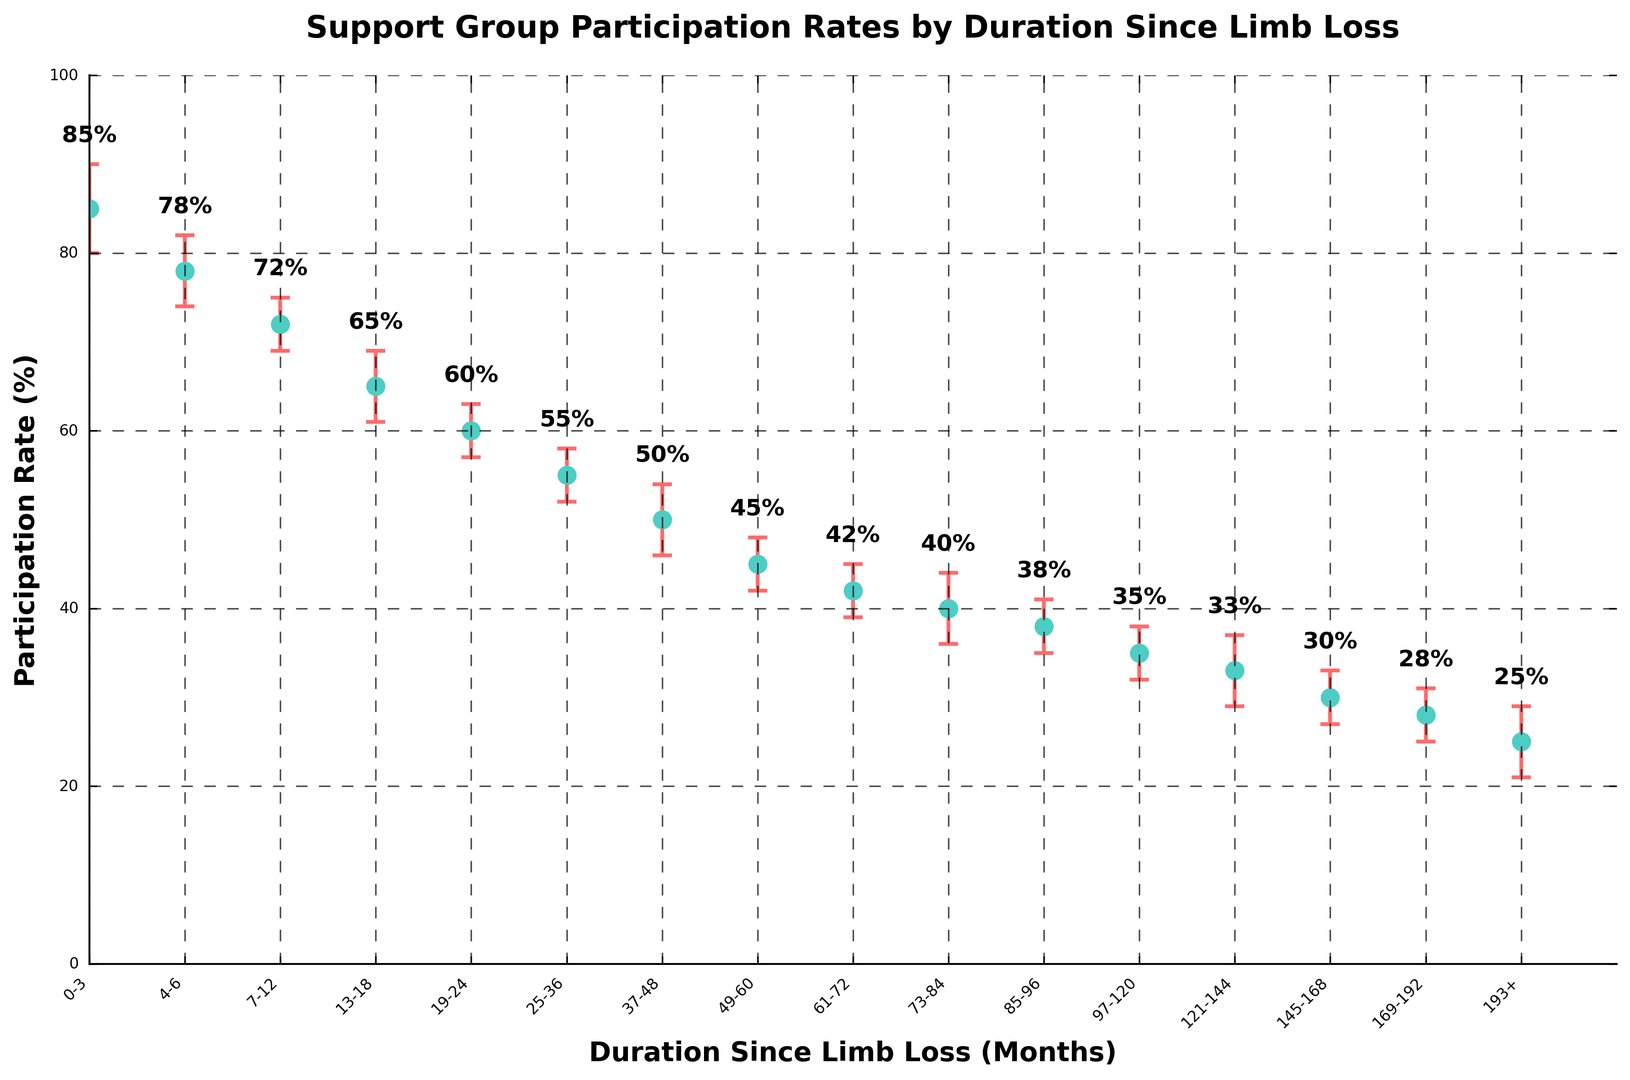Which duration since limb loss has the highest participation rate? To find the duration with the highest participation rate, look at the values on the y-axis and identify the corresponding x-axis label. The highest rate is 85%, and it is for the duration 0-3 months.
Answer: 0-3 months What is the participation rate for those with 4-6 months since limb loss? Locate the 4-6 months label on the x-axis and find the corresponding point on the y-axis. The participation rate is 78%.
Answer: 78% Is the participation rate for 7-12 months greater than or less than the rate for 13-18 months? Compare the participation rates of 72% and 65% for 7-12 months and 13-18 months, respectively. 72% is greater than 65%.
Answer: Greater What is the difference in participation rates between those with 61-72 months and those with 193+ months since limb loss? Locate the points for 61-72 months and 193+ months, which are 42% and 25% respectively. Subtract 25% from 42% to get 17%.
Answer: 17% What is the trend in participation rates as the duration since limb loss increases? Observe the figure and note the general direction of the points. The participation rate decreases as the duration since limb loss increases.
Answer: Decreases What is the error margin for the participation rate at 25-36 months since limb loss? Find the error bars for the 25-36 months point on the x-axis, which shows an error margin of ±3%.
Answer: ±3% How many data points have participation rates above 50%? Count the points that are positioned above the 50% mark on the y-axis. There are six data points with participation rates above 50%.
Answer: 6 Which duration since limb loss has a participation rate of 38%? Find the point on the y-axis with a participation rate of 38%, and match it to the corresponding x-axis label which is 85-96 months.
Answer: 85-96 months What is the average participation rate for the first three durations since limb loss (0-3 months, 4-6 months, 7-12 months)? Add the participation rates: 85% + 78% + 72% = 235%. Then divide by 3 to get the average: 235% / 3 = 78.33%.
Answer: 78.33% Is the participation rate for 97-120 months higher or lower than the error margin for 37-48 months? The participation rate for 97-120 months is 35%, and the error margin for 37-48 months is 4%. The participation rate is higher than the error margin.
Answer: Higher 